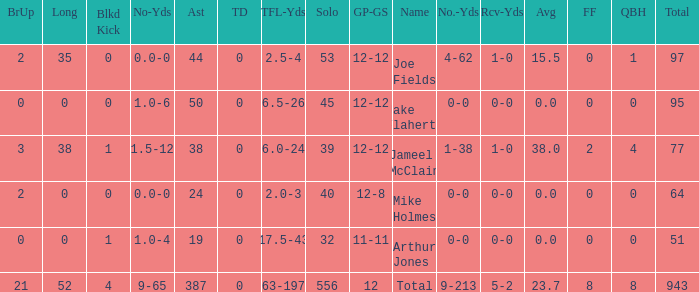What is the largest number of tds scored for a player? 0.0. 